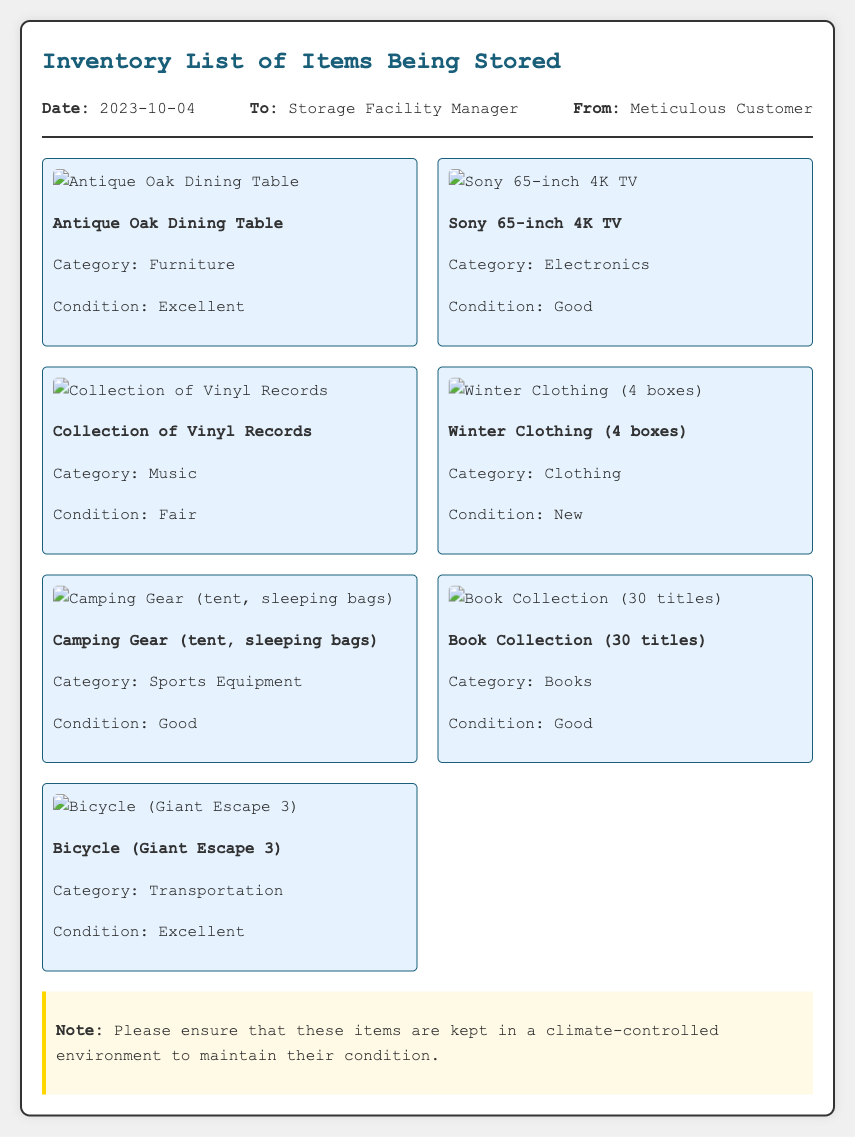What is the storage date? The storage date is stated at the top of the memo, which is 2023-10-04.
Answer: 2023-10-04 What is the condition of the Sony TV? The condition of the Sony TV is mentioned in the inventory section, listed as Good.
Answer: Good How many boxes of winter clothing are being stored? The number of boxes of winter clothing is specified in the inventory list as 4 boxes.
Answer: 4 boxes Which item is categorized as Furniture? The inventory shows that the Antique Oak Dining Table falls under the Furniture category.
Answer: Antique Oak Dining Table What is the overall note regarding item storage? The note highlights that these items should be kept in a climate-controlled environment.
Answer: Climate-controlled environment What category does the bicycle belong to? In the inventory list, the bicycle is categorized under Transportation.
Answer: Transportation What is the condition of the collection of vinyl records? The condition of the collection of vinyl records is stated as Fair.
Answer: Fair Who is the memo addressed to? The memo specifies that it is addressed to the Storage Facility Manager.
Answer: Storage Facility Manager 